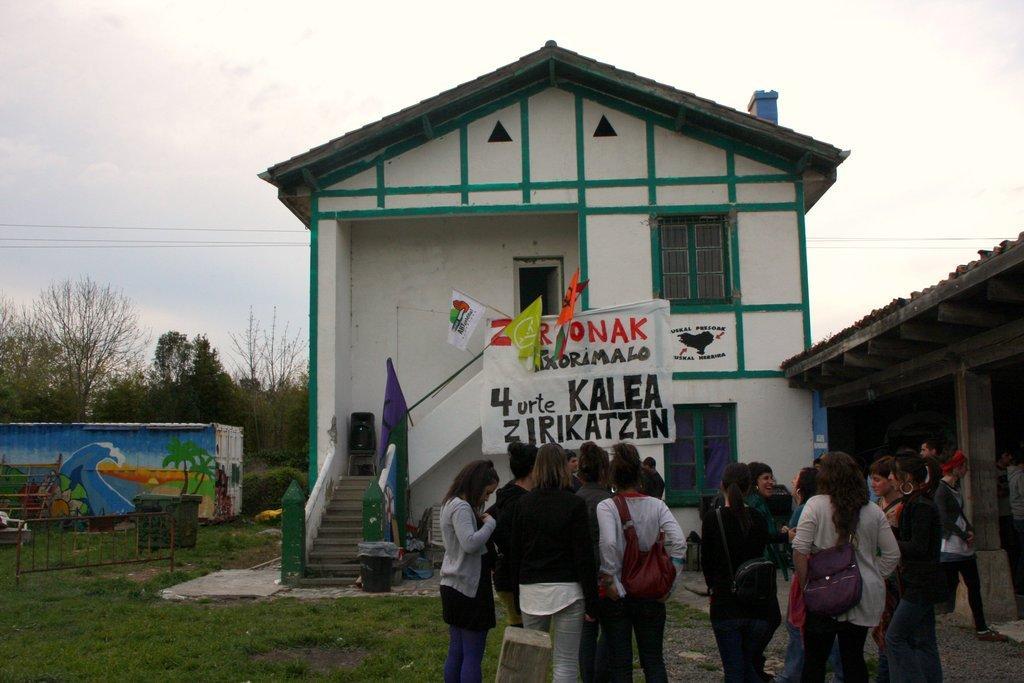Describe this image in one or two sentences. In this picture I can see number of people in front who are standing and on the left side of them I can see the grass. In the middle of this picture I see few buildings and I can see few flags and a cloth on a building which is on the center of this picture and I see something is written on the cloth. In the background I can see number of trees, wires and the sky and I can see a container on which there is an art. 